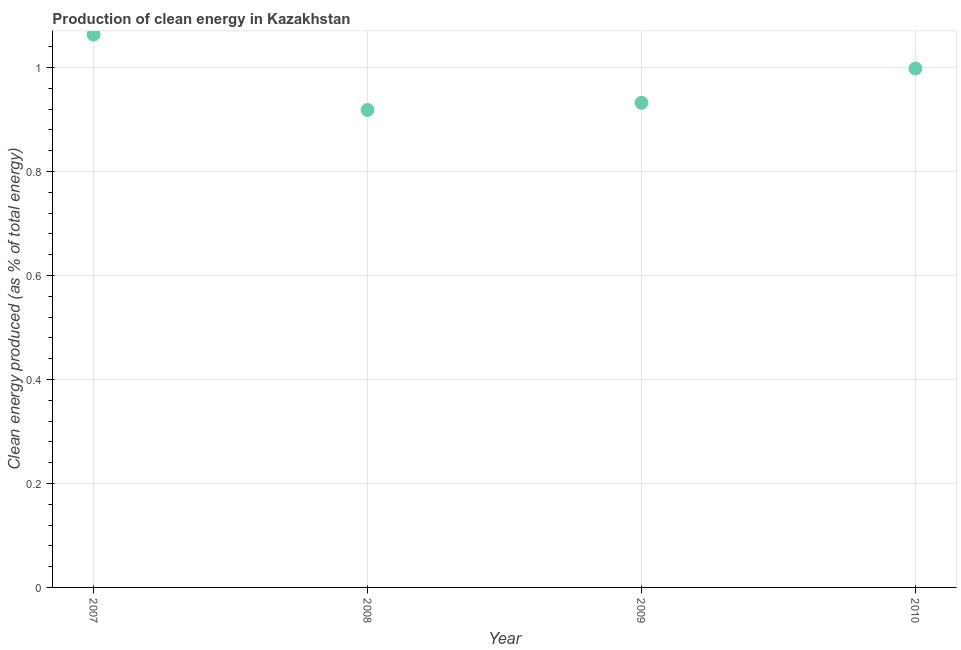What is the production of clean energy in 2010?
Provide a succinct answer. 1. Across all years, what is the maximum production of clean energy?
Offer a terse response. 1.06. Across all years, what is the minimum production of clean energy?
Provide a succinct answer. 0.92. What is the sum of the production of clean energy?
Provide a succinct answer. 3.91. What is the difference between the production of clean energy in 2007 and 2009?
Your answer should be compact. 0.13. What is the average production of clean energy per year?
Your answer should be very brief. 0.98. What is the median production of clean energy?
Provide a succinct answer. 0.97. In how many years, is the production of clean energy greater than 0.28 %?
Your answer should be very brief. 4. Do a majority of the years between 2007 and 2008 (inclusive) have production of clean energy greater than 0.6000000000000001 %?
Ensure brevity in your answer.  Yes. What is the ratio of the production of clean energy in 2007 to that in 2009?
Offer a very short reply. 1.14. Is the production of clean energy in 2009 less than that in 2010?
Your response must be concise. Yes. Is the difference between the production of clean energy in 2008 and 2009 greater than the difference between any two years?
Offer a terse response. No. What is the difference between the highest and the second highest production of clean energy?
Keep it short and to the point. 0.07. Is the sum of the production of clean energy in 2008 and 2010 greater than the maximum production of clean energy across all years?
Keep it short and to the point. Yes. What is the difference between the highest and the lowest production of clean energy?
Give a very brief answer. 0.14. Does the production of clean energy monotonically increase over the years?
Provide a succinct answer. No. How many dotlines are there?
Your response must be concise. 1. What is the difference between two consecutive major ticks on the Y-axis?
Your answer should be very brief. 0.2. Does the graph contain any zero values?
Your response must be concise. No. Does the graph contain grids?
Provide a succinct answer. Yes. What is the title of the graph?
Ensure brevity in your answer.  Production of clean energy in Kazakhstan. What is the label or title of the Y-axis?
Offer a terse response. Clean energy produced (as % of total energy). What is the Clean energy produced (as % of total energy) in 2007?
Your answer should be very brief. 1.06. What is the Clean energy produced (as % of total energy) in 2008?
Your answer should be compact. 0.92. What is the Clean energy produced (as % of total energy) in 2009?
Offer a terse response. 0.93. What is the Clean energy produced (as % of total energy) in 2010?
Make the answer very short. 1. What is the difference between the Clean energy produced (as % of total energy) in 2007 and 2008?
Keep it short and to the point. 0.14. What is the difference between the Clean energy produced (as % of total energy) in 2007 and 2009?
Make the answer very short. 0.13. What is the difference between the Clean energy produced (as % of total energy) in 2007 and 2010?
Provide a short and direct response. 0.07. What is the difference between the Clean energy produced (as % of total energy) in 2008 and 2009?
Make the answer very short. -0.01. What is the difference between the Clean energy produced (as % of total energy) in 2008 and 2010?
Ensure brevity in your answer.  -0.08. What is the difference between the Clean energy produced (as % of total energy) in 2009 and 2010?
Make the answer very short. -0.07. What is the ratio of the Clean energy produced (as % of total energy) in 2007 to that in 2008?
Give a very brief answer. 1.16. What is the ratio of the Clean energy produced (as % of total energy) in 2007 to that in 2009?
Your answer should be very brief. 1.14. What is the ratio of the Clean energy produced (as % of total energy) in 2007 to that in 2010?
Your response must be concise. 1.06. What is the ratio of the Clean energy produced (as % of total energy) in 2008 to that in 2009?
Your answer should be compact. 0.98. What is the ratio of the Clean energy produced (as % of total energy) in 2009 to that in 2010?
Your answer should be very brief. 0.93. 